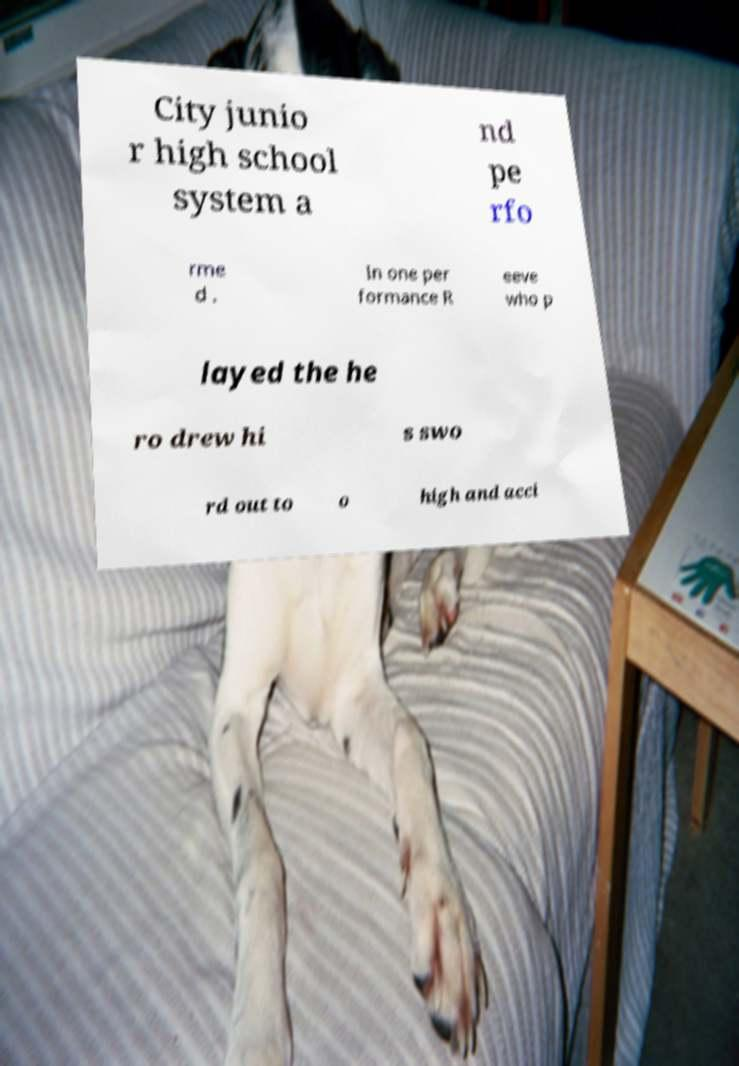Could you assist in decoding the text presented in this image and type it out clearly? City junio r high school system a nd pe rfo rme d . In one per formance R eeve who p layed the he ro drew hi s swo rd out to o high and acci 